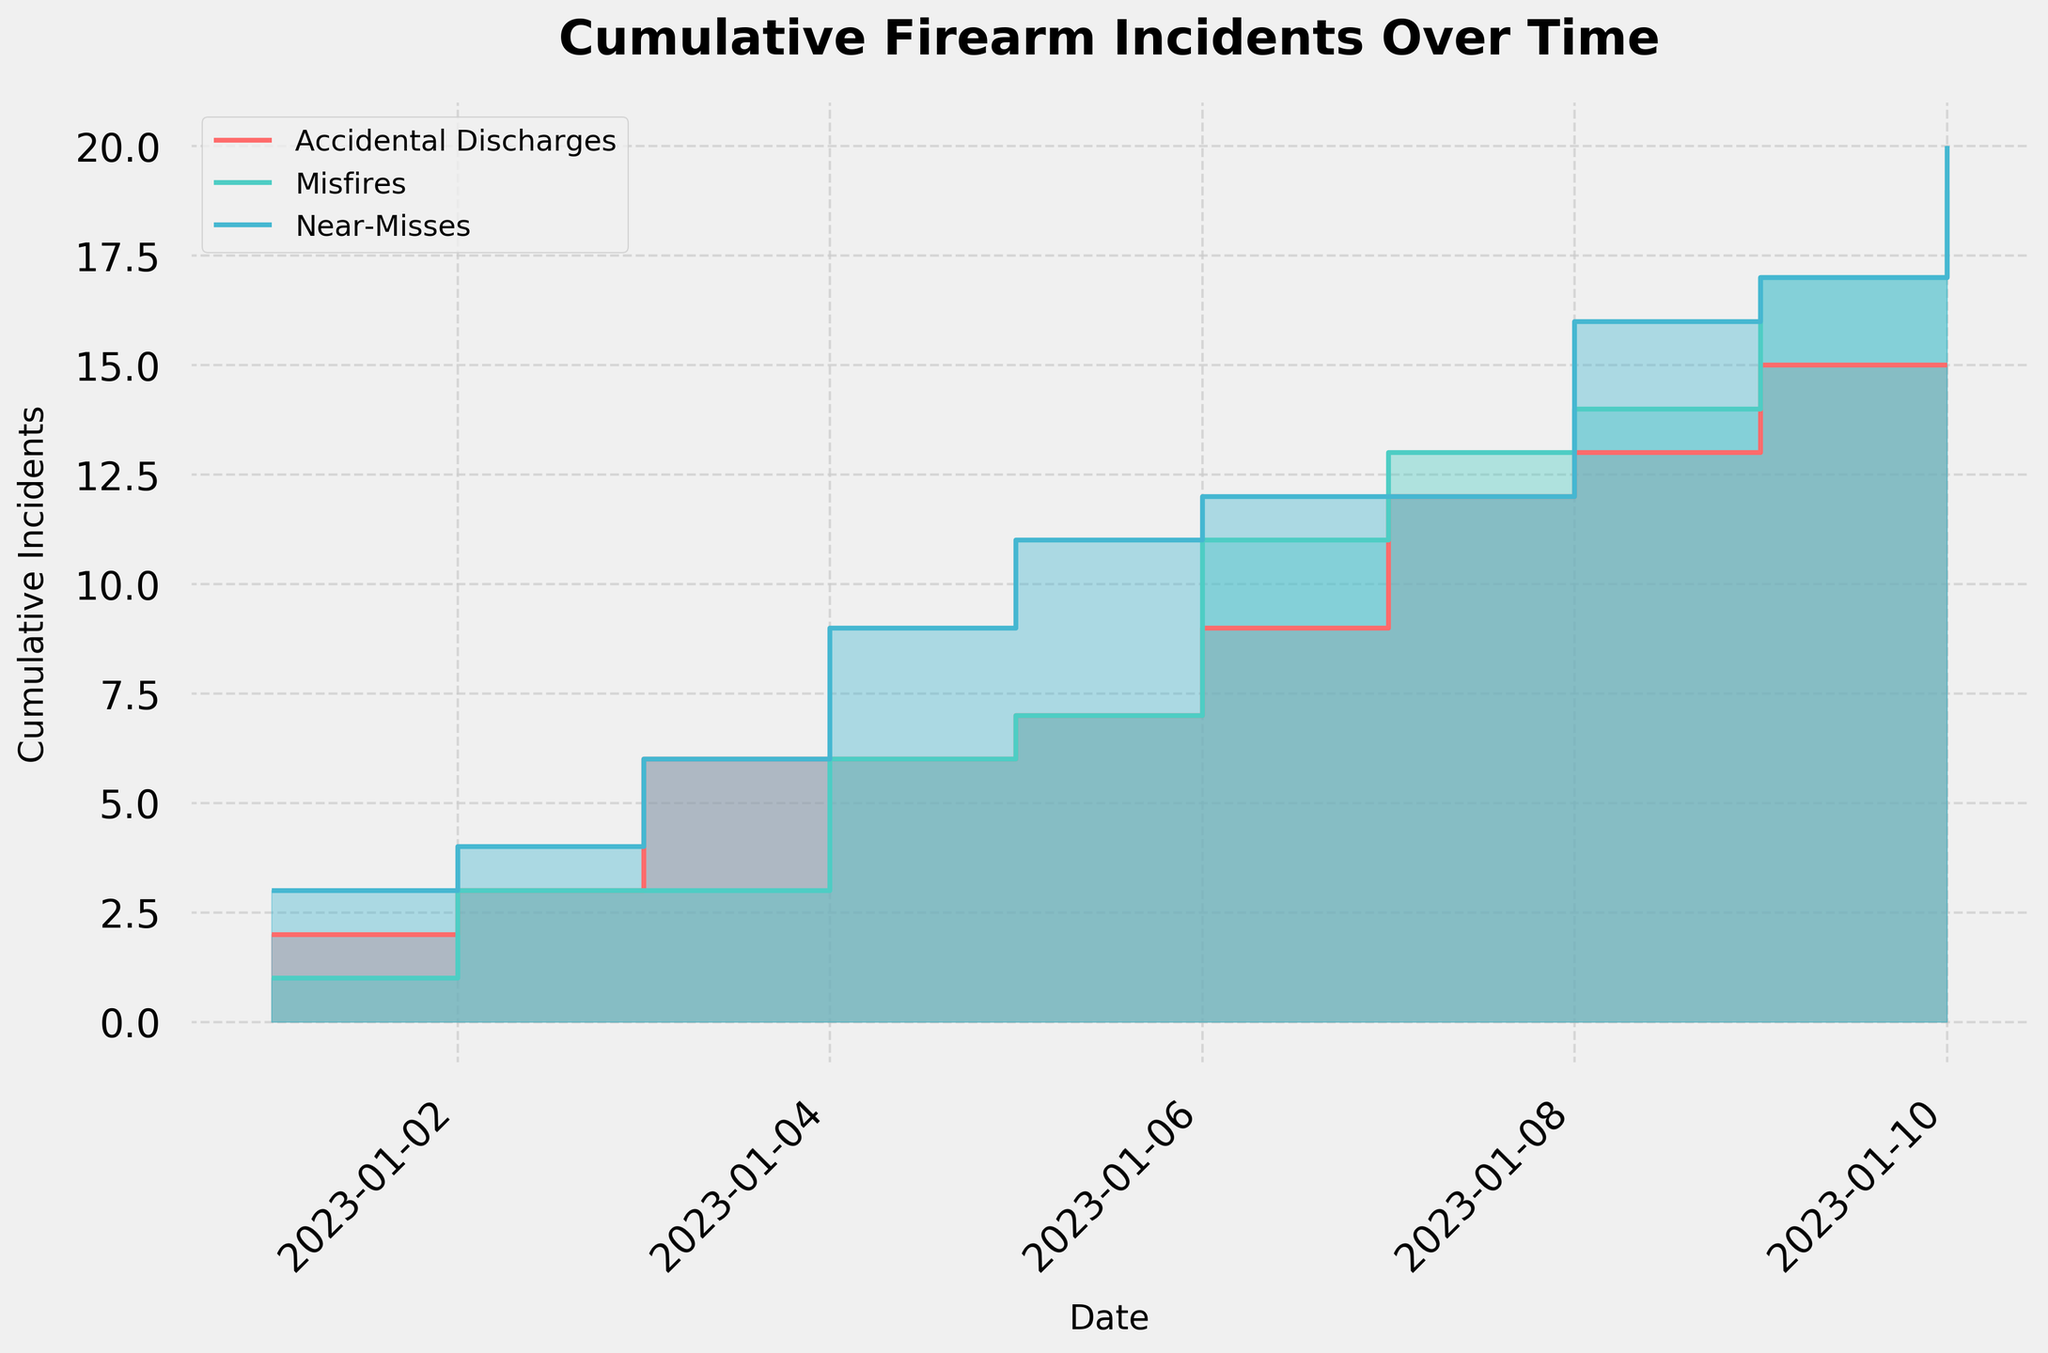What is the title of the chart? The title is usually at the top of the chart and provides a concise summary. In this case, it reads 'Cumulative Firearm Incidents Over Time'.
Answer: Cumulative Firearm Incidents Over Time What colors are used to differentiate between the different categories of incidents? The colors used to represent different categories can be seen in the legend and the chart itself. Accidental Discharges are represented in red, Misfires in teal, and Near-Misses in blue.
Answer: Red, teal, blue How many data points are plotted in the chart? The line segment changes at the boundaries of each day's data point, so there are as many data points as there are days listed on the x-axis. The data spans from January 1st to January 10th, which totals 10 days.
Answer: 10 On which date did 'Misfires' first surpass 'Accidental Discharges' in cumulative incidents? To answer this, we need to visually identify where the teal line for Misfires crosses above the red line for Accidental Discharges. This first occurs on January 4th.
Answer: January 4th What was the cumulative number of 'Near-Misses' by January 5? The cumulative count for Near-Misses by January 5 can be found by visually summing up the values up to that date, or checking the blue step at that point. By January 5, the cumulative number of Near-Misses is 11.
Answer: 11 Which category has the highest cumulative incidents by the end of the period (January 10)? Visually compare the end points of the lines. The line that ends at the highest vertical position represents the category with the highest cumulative incidents. Near-Misses, represented by the blue line, has the highest cumulative incidents.
Answer: Near-Misses Which day showed the largest increase in cumulative 'Misfires'? Evaluate the steepness of the step for Misfires (teal) in the plot. The steepest increase is on January 6, where the cumulative Misfires increase by 4.
Answer: January 6 By how much did 'Accidental Discharges' increase from January 2 to January 3? Examine the steps between January 2 and January 3 for the red line. The cumulative increase from 3 on January 2 to 6 on January 3 shows an increase of 3.
Answer: 3 How does the trend in 'Near-Misses' compare to the trend in 'Accidental Discharges'? Compare the overall slope and the steps in the blue line (Near-Misses) and the red line (Accidental Discharges). Near-Misses have a more consistent and faster cumulative increase over the period compared to the more variable and slower increase in Accidental Discharges.
Answer: Near-Misses have a faster increase What is the total number of incidents recorded (all categories combined) by January 8? To find this, sum the cumulative incidents of all categories by January 8. Accidental Discharges: 12, Misfires: 16, Near-Misses: 16. Their total is 12 + 16 + 16 = 44.
Answer: 44 